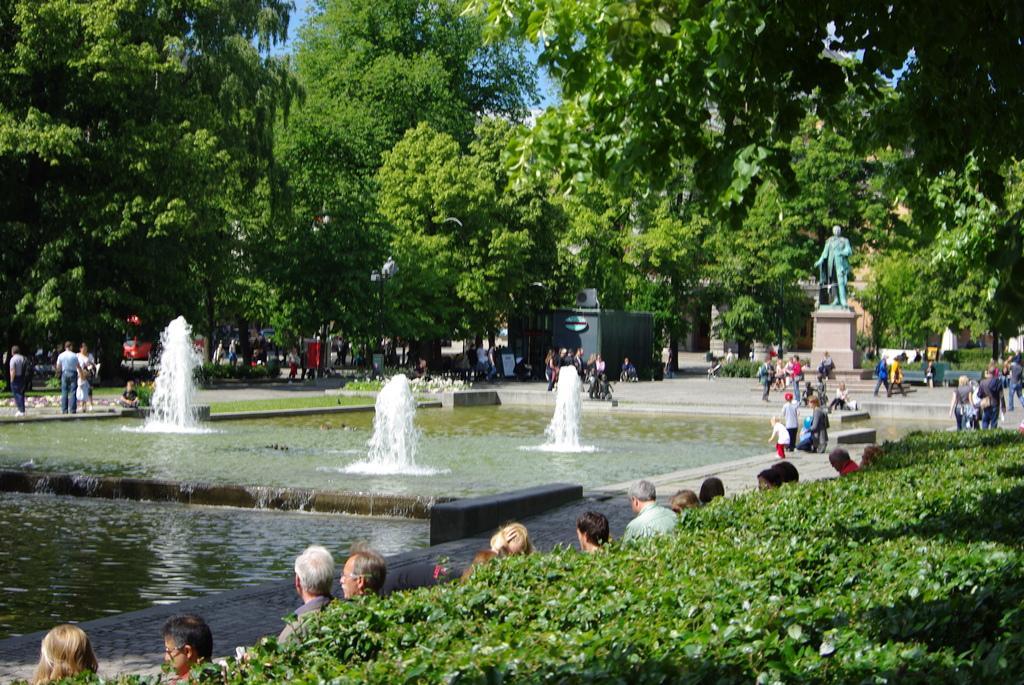In one or two sentences, can you explain what this image depicts? In this image, we can see few people, water fountains, grass, plants, trees, shed, statue, vehicle, benches. Background there is a sky. 